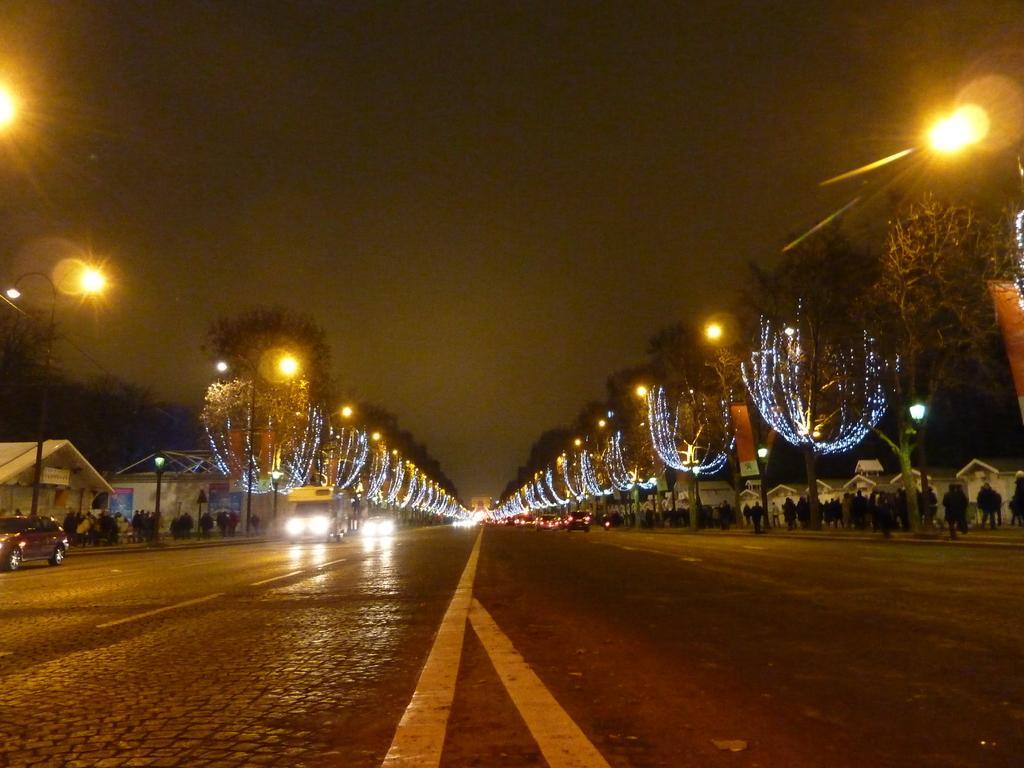How would you summarize this image in a sentence or two? This picture is clicked outside the city. At the bottom of the picture, we see the road. On either side of the picture, we see street lights and buildings. This road is decorated with the lights. On either side of the picture, we see people are walking on the footpath. At the top of the picture, we see the sky. This picture is clicked in the dark. 